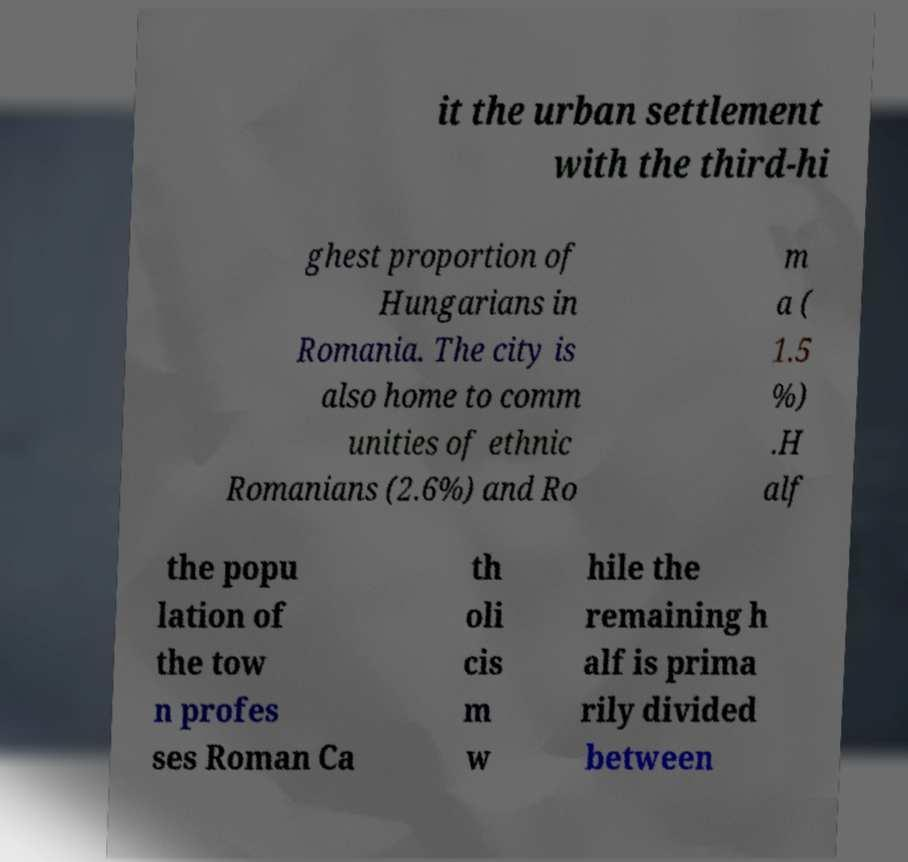Could you assist in decoding the text presented in this image and type it out clearly? it the urban settlement with the third-hi ghest proportion of Hungarians in Romania. The city is also home to comm unities of ethnic Romanians (2.6%) and Ro m a ( 1.5 %) .H alf the popu lation of the tow n profes ses Roman Ca th oli cis m w hile the remaining h alf is prima rily divided between 